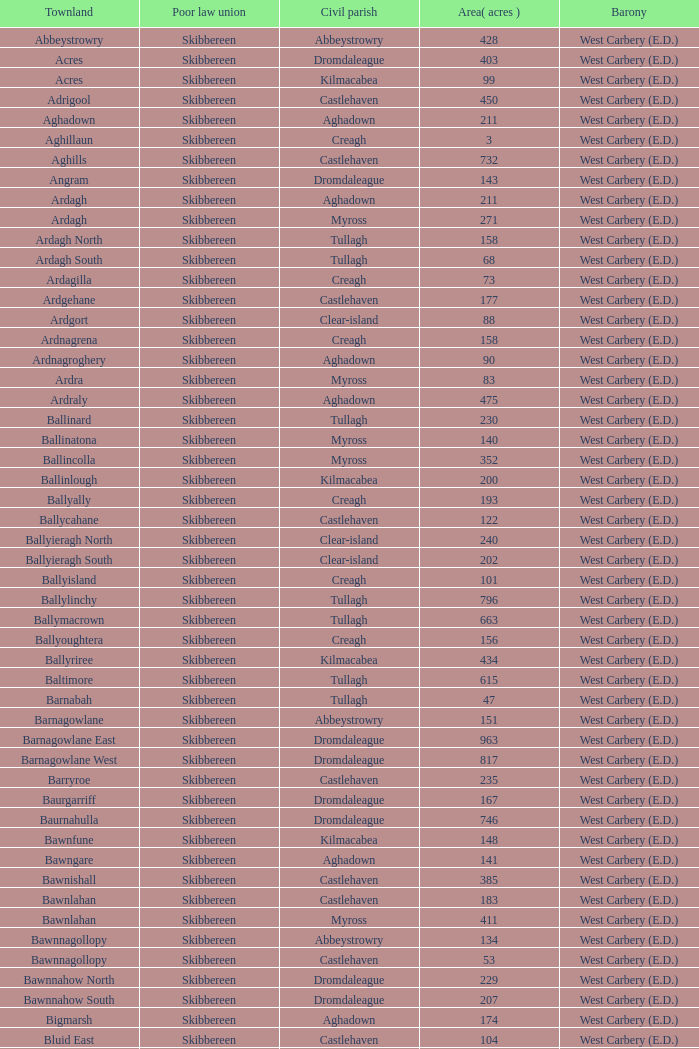What are the areas (in acres) of the Kilnahera East townland? 257.0. 